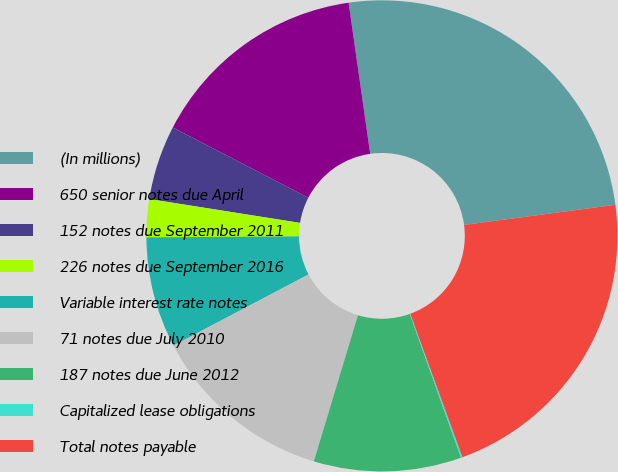Convert chart. <chart><loc_0><loc_0><loc_500><loc_500><pie_chart><fcel>(In millions)<fcel>650 senior notes due April<fcel>152 notes due September 2011<fcel>226 notes due September 2016<fcel>Variable interest rate notes<fcel>71 notes due July 2010<fcel>187 notes due June 2012<fcel>Capitalized lease obligations<fcel>Total notes payable<nl><fcel>25.15%<fcel>15.13%<fcel>5.11%<fcel>2.6%<fcel>7.61%<fcel>12.62%<fcel>10.12%<fcel>0.1%<fcel>21.55%<nl></chart> 